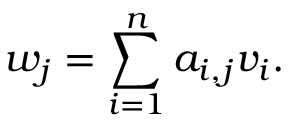Convert formula to latex. <formula><loc_0><loc_0><loc_500><loc_500>w _ { j } = \sum _ { i = 1 } ^ { n } a _ { i , j } v _ { i } .</formula> 